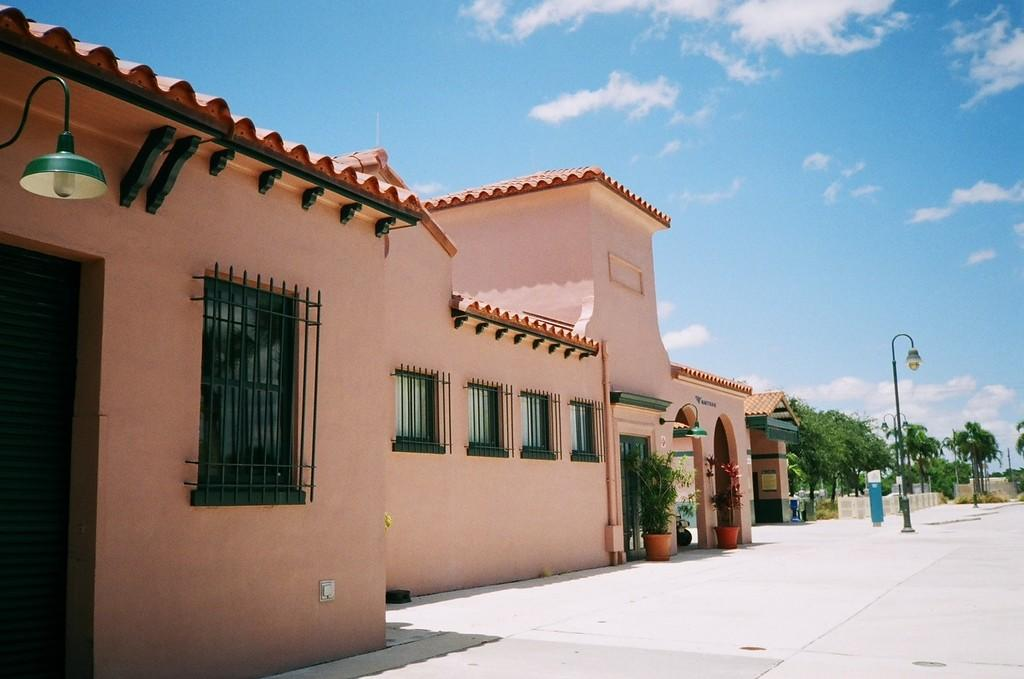What is the main structure in the middle of the image? There is a building in the middle of the image. What features can be observed on the building? The building has windows. What type of vegetation is present on the right side of the image? There are plants and trees on the right side of the image. What is visible at the top of the image? The sky is visible at the top of the image. What can be seen in the middle of the image besides the building? There are lights in the middle of the image. What type of cactus is present on the left side of the image? There is no cactus present on the left side of the image. What texture can be seen on the plate in the image? There is no plate present in the image. 